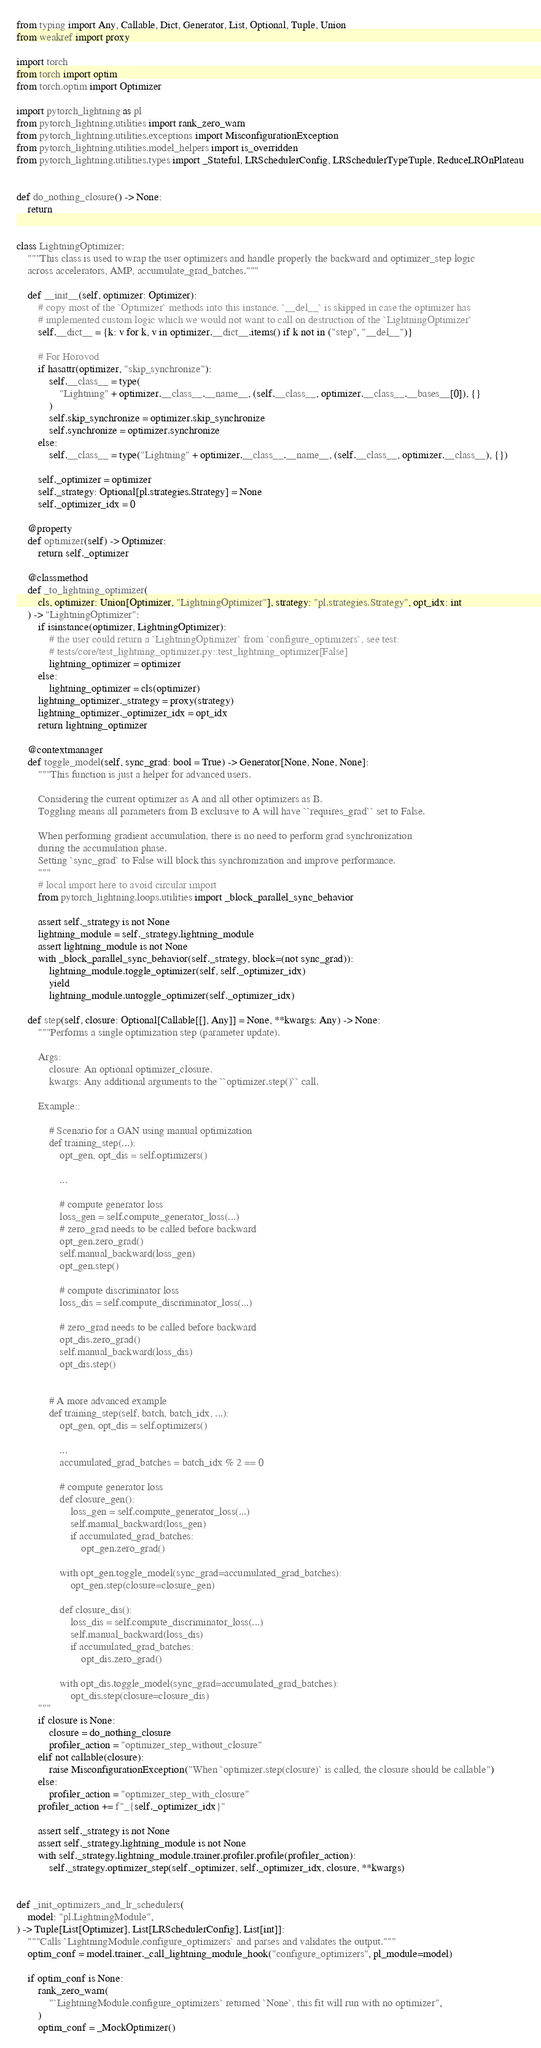Convert code to text. <code><loc_0><loc_0><loc_500><loc_500><_Python_>from typing import Any, Callable, Dict, Generator, List, Optional, Tuple, Union
from weakref import proxy

import torch
from torch import optim
from torch.optim import Optimizer

import pytorch_lightning as pl
from pytorch_lightning.utilities import rank_zero_warn
from pytorch_lightning.utilities.exceptions import MisconfigurationException
from pytorch_lightning.utilities.model_helpers import is_overridden
from pytorch_lightning.utilities.types import _Stateful, LRSchedulerConfig, LRSchedulerTypeTuple, ReduceLROnPlateau


def do_nothing_closure() -> None:
    return


class LightningOptimizer:
    """This class is used to wrap the user optimizers and handle properly the backward and optimizer_step logic
    across accelerators, AMP, accumulate_grad_batches."""

    def __init__(self, optimizer: Optimizer):
        # copy most of the `Optimizer` methods into this instance. `__del__` is skipped in case the optimizer has
        # implemented custom logic which we would not want to call on destruction of the `LightningOptimizer`
        self.__dict__ = {k: v for k, v in optimizer.__dict__.items() if k not in ("step", "__del__")}

        # For Horovod
        if hasattr(optimizer, "skip_synchronize"):
            self.__class__ = type(
                "Lightning" + optimizer.__class__.__name__, (self.__class__, optimizer.__class__.__bases__[0]), {}
            )
            self.skip_synchronize = optimizer.skip_synchronize
            self.synchronize = optimizer.synchronize
        else:
            self.__class__ = type("Lightning" + optimizer.__class__.__name__, (self.__class__, optimizer.__class__), {})

        self._optimizer = optimizer
        self._strategy: Optional[pl.strategies.Strategy] = None
        self._optimizer_idx = 0

    @property
    def optimizer(self) -> Optimizer:
        return self._optimizer

    @classmethod
    def _to_lightning_optimizer(
        cls, optimizer: Union[Optimizer, "LightningOptimizer"], strategy: "pl.strategies.Strategy", opt_idx: int
    ) -> "LightningOptimizer":
        if isinstance(optimizer, LightningOptimizer):
            # the user could return a `LightningOptimizer` from `configure_optimizers`, see test:
            # tests/core/test_lightning_optimizer.py::test_lightning_optimizer[False]
            lightning_optimizer = optimizer
        else:
            lightning_optimizer = cls(optimizer)
        lightning_optimizer._strategy = proxy(strategy)
        lightning_optimizer._optimizer_idx = opt_idx
        return lightning_optimizer

    @contextmanager
    def toggle_model(self, sync_grad: bool = True) -> Generator[None, None, None]:
        """This function is just a helper for advanced users.

        Considering the current optimizer as A and all other optimizers as B.
        Toggling means all parameters from B exclusive to A will have ``requires_grad`` set to False.

        When performing gradient accumulation, there is no need to perform grad synchronization
        during the accumulation phase.
        Setting `sync_grad` to False will block this synchronization and improve performance.
        """
        # local import here to avoid circular import
        from pytorch_lightning.loops.utilities import _block_parallel_sync_behavior

        assert self._strategy is not None
        lightning_module = self._strategy.lightning_module
        assert lightning_module is not None
        with _block_parallel_sync_behavior(self._strategy, block=(not sync_grad)):
            lightning_module.toggle_optimizer(self, self._optimizer_idx)
            yield
            lightning_module.untoggle_optimizer(self._optimizer_idx)

    def step(self, closure: Optional[Callable[[], Any]] = None, **kwargs: Any) -> None:
        """Performs a single optimization step (parameter update).

        Args:
            closure: An optional optimizer_closure.
            kwargs: Any additional arguments to the ``optimizer.step()`` call.

        Example::

            # Scenario for a GAN using manual optimization
            def training_step(...):
                opt_gen, opt_dis = self.optimizers()

                ...

                # compute generator loss
                loss_gen = self.compute_generator_loss(...)
                # zero_grad needs to be called before backward
                opt_gen.zero_grad()
                self.manual_backward(loss_gen)
                opt_gen.step()

                # compute discriminator loss
                loss_dis = self.compute_discriminator_loss(...)

                # zero_grad needs to be called before backward
                opt_dis.zero_grad()
                self.manual_backward(loss_dis)
                opt_dis.step()


            # A more advanced example
            def training_step(self, batch, batch_idx, ...):
                opt_gen, opt_dis = self.optimizers()

                ...
                accumulated_grad_batches = batch_idx % 2 == 0

                # compute generator loss
                def closure_gen():
                    loss_gen = self.compute_generator_loss(...)
                    self.manual_backward(loss_gen)
                    if accumulated_grad_batches:
                        opt_gen.zero_grad()

                with opt_gen.toggle_model(sync_grad=accumulated_grad_batches):
                    opt_gen.step(closure=closure_gen)

                def closure_dis():
                    loss_dis = self.compute_discriminator_loss(...)
                    self.manual_backward(loss_dis)
                    if accumulated_grad_batches:
                        opt_dis.zero_grad()

                with opt_dis.toggle_model(sync_grad=accumulated_grad_batches):
                    opt_dis.step(closure=closure_dis)
        """
        if closure is None:
            closure = do_nothing_closure
            profiler_action = "optimizer_step_without_closure"
        elif not callable(closure):
            raise MisconfigurationException("When `optimizer.step(closure)` is called, the closure should be callable")
        else:
            profiler_action = "optimizer_step_with_closure"
        profiler_action += f"_{self._optimizer_idx}"

        assert self._strategy is not None
        assert self._strategy.lightning_module is not None
        with self._strategy.lightning_module.trainer.profiler.profile(profiler_action):
            self._strategy.optimizer_step(self._optimizer, self._optimizer_idx, closure, **kwargs)


def _init_optimizers_and_lr_schedulers(
    model: "pl.LightningModule",
) -> Tuple[List[Optimizer], List[LRSchedulerConfig], List[int]]:
    """Calls `LightningModule.configure_optimizers` and parses and validates the output."""
    optim_conf = model.trainer._call_lightning_module_hook("configure_optimizers", pl_module=model)

    if optim_conf is None:
        rank_zero_warn(
            "`LightningModule.configure_optimizers` returned `None`, this fit will run with no optimizer",
        )
        optim_conf = _MockOptimizer()
</code> 